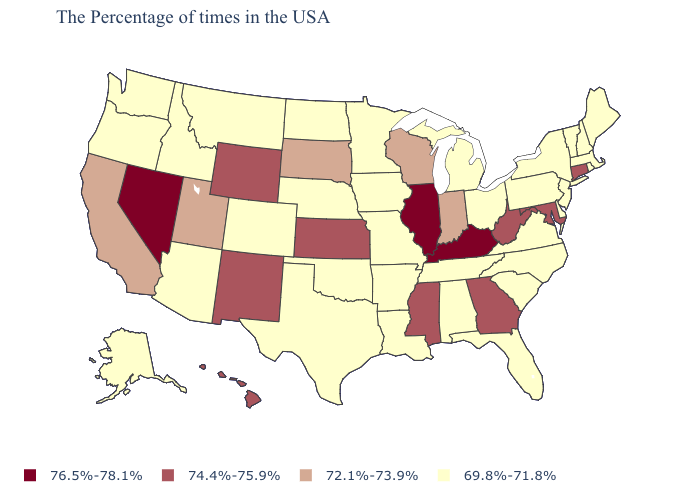Name the states that have a value in the range 74.4%-75.9%?
Concise answer only. Connecticut, Maryland, West Virginia, Georgia, Mississippi, Kansas, Wyoming, New Mexico, Hawaii. Name the states that have a value in the range 69.8%-71.8%?
Write a very short answer. Maine, Massachusetts, Rhode Island, New Hampshire, Vermont, New York, New Jersey, Delaware, Pennsylvania, Virginia, North Carolina, South Carolina, Ohio, Florida, Michigan, Alabama, Tennessee, Louisiana, Missouri, Arkansas, Minnesota, Iowa, Nebraska, Oklahoma, Texas, North Dakota, Colorado, Montana, Arizona, Idaho, Washington, Oregon, Alaska. Does North Dakota have the same value as Alabama?
Concise answer only. Yes. Among the states that border Colorado , which have the lowest value?
Be succinct. Nebraska, Oklahoma, Arizona. What is the value of New Mexico?
Quick response, please. 74.4%-75.9%. Among the states that border Oregon , which have the highest value?
Give a very brief answer. Nevada. Does Oregon have the lowest value in the USA?
Keep it brief. Yes. Name the states that have a value in the range 76.5%-78.1%?
Keep it brief. Kentucky, Illinois, Nevada. What is the value of Illinois?
Be succinct. 76.5%-78.1%. What is the value of North Dakota?
Short answer required. 69.8%-71.8%. What is the value of Texas?
Concise answer only. 69.8%-71.8%. Does Indiana have the highest value in the USA?
Concise answer only. No. 